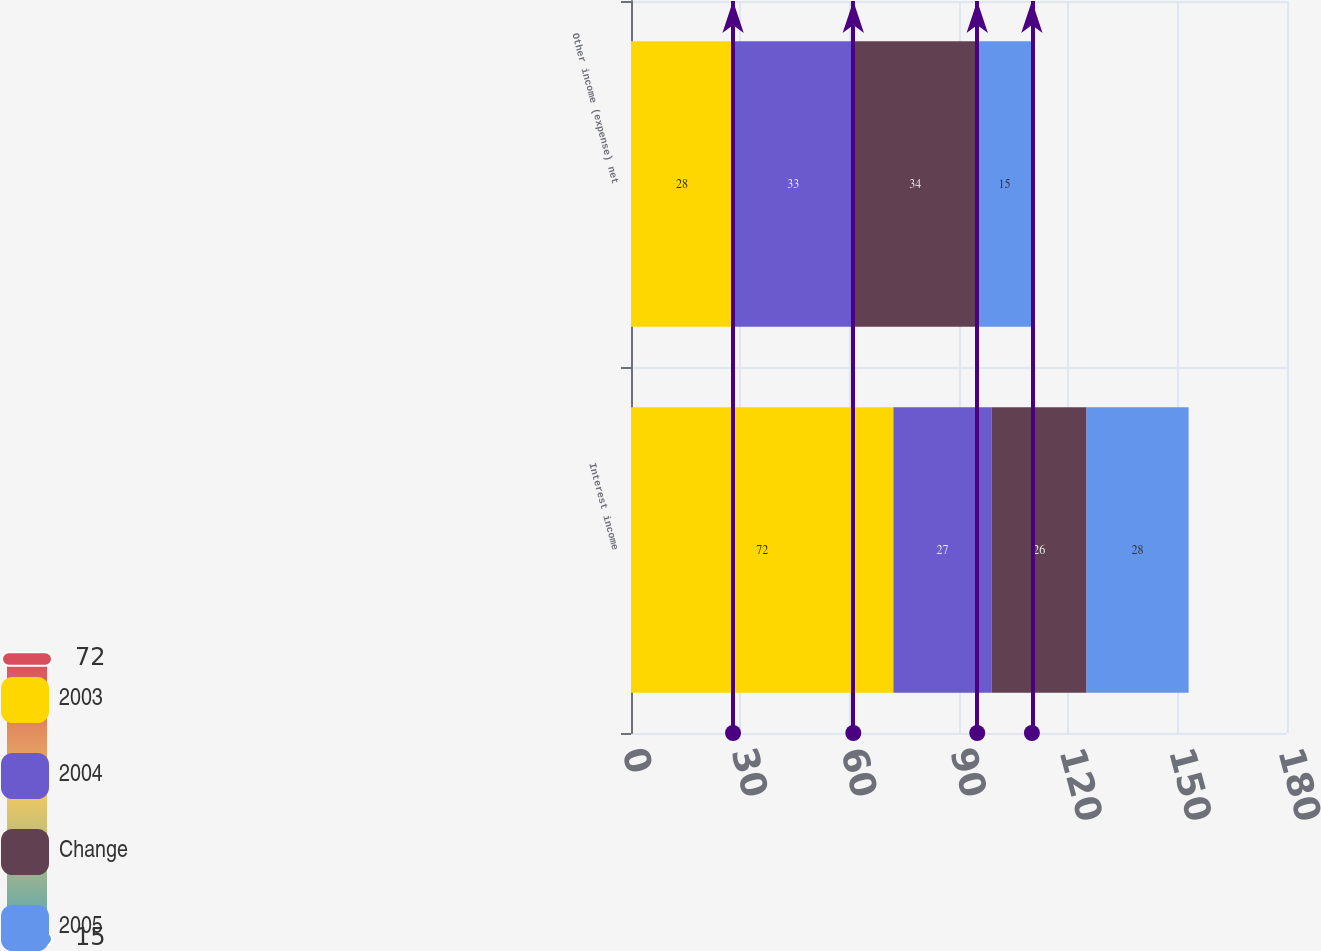<chart> <loc_0><loc_0><loc_500><loc_500><stacked_bar_chart><ecel><fcel>Interest income<fcel>Other income (expense) net<nl><fcel>2003<fcel>72<fcel>28<nl><fcel>2004<fcel>27<fcel>33<nl><fcel>Change<fcel>26<fcel>34<nl><fcel>2005<fcel>28<fcel>15<nl></chart> 